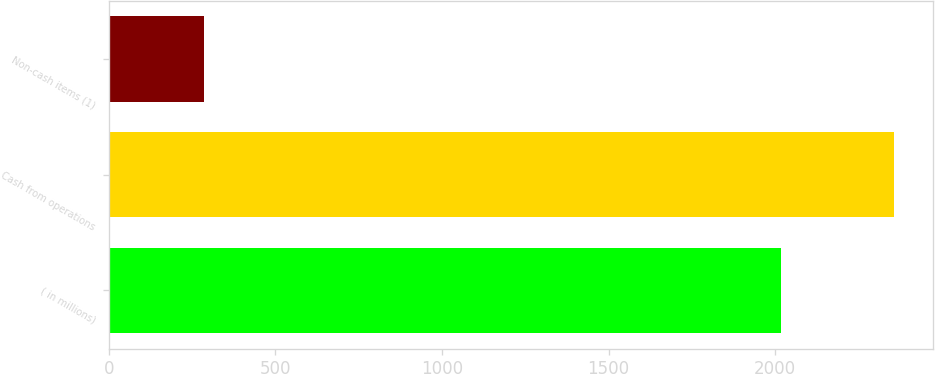Convert chart to OTSL. <chart><loc_0><loc_0><loc_500><loc_500><bar_chart><fcel>( in millions)<fcel>Cash from operations<fcel>Non-cash items (1)<nl><fcel>2018<fcel>2357<fcel>287<nl></chart> 